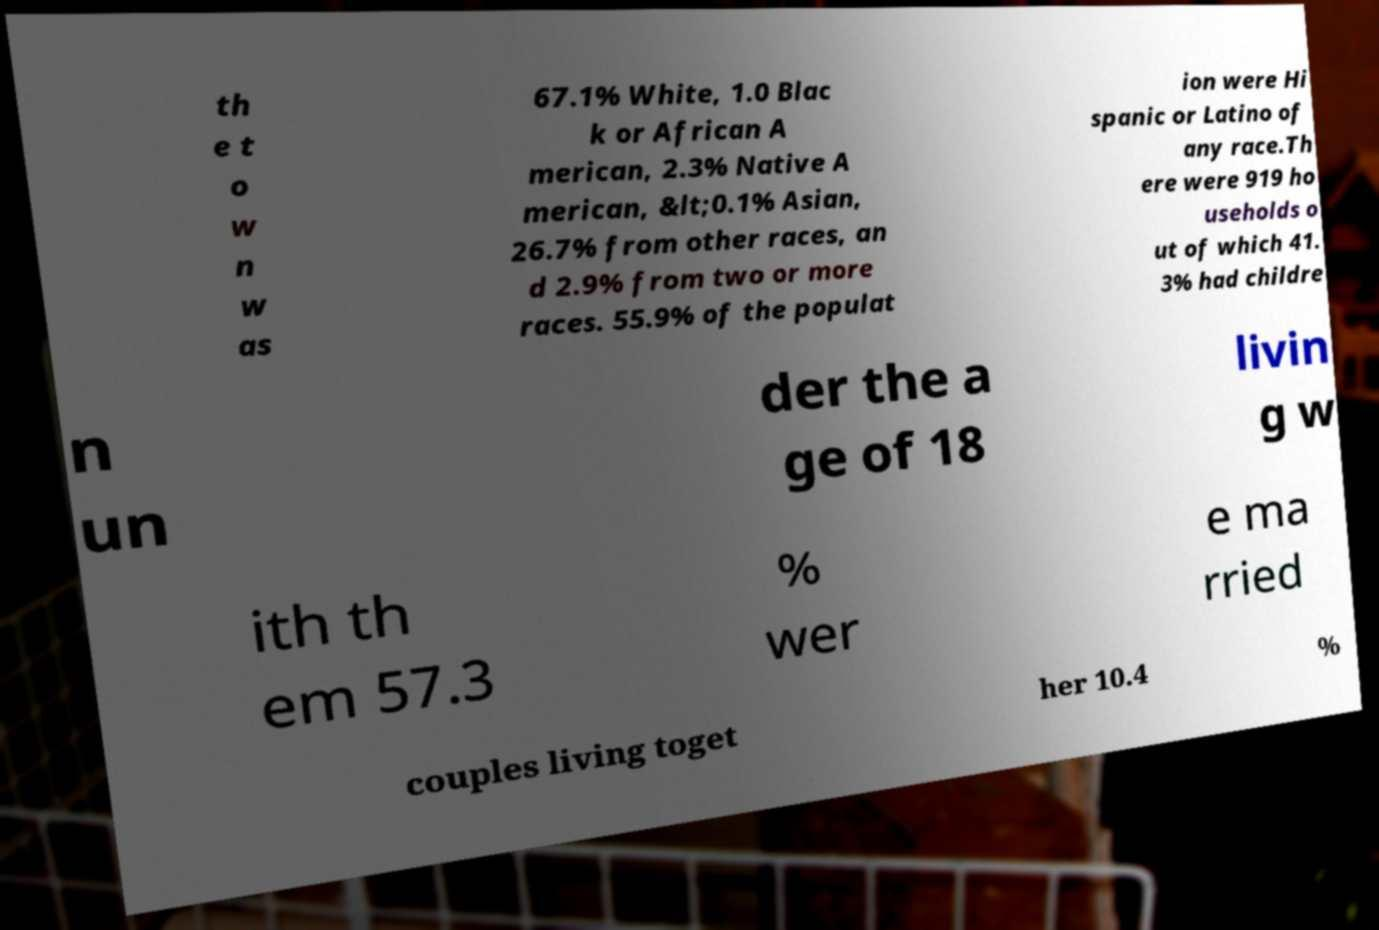I need the written content from this picture converted into text. Can you do that? th e t o w n w as 67.1% White, 1.0 Blac k or African A merican, 2.3% Native A merican, &lt;0.1% Asian, 26.7% from other races, an d 2.9% from two or more races. 55.9% of the populat ion were Hi spanic or Latino of any race.Th ere were 919 ho useholds o ut of which 41. 3% had childre n un der the a ge of 18 livin g w ith th em 57.3 % wer e ma rried couples living toget her 10.4 % 